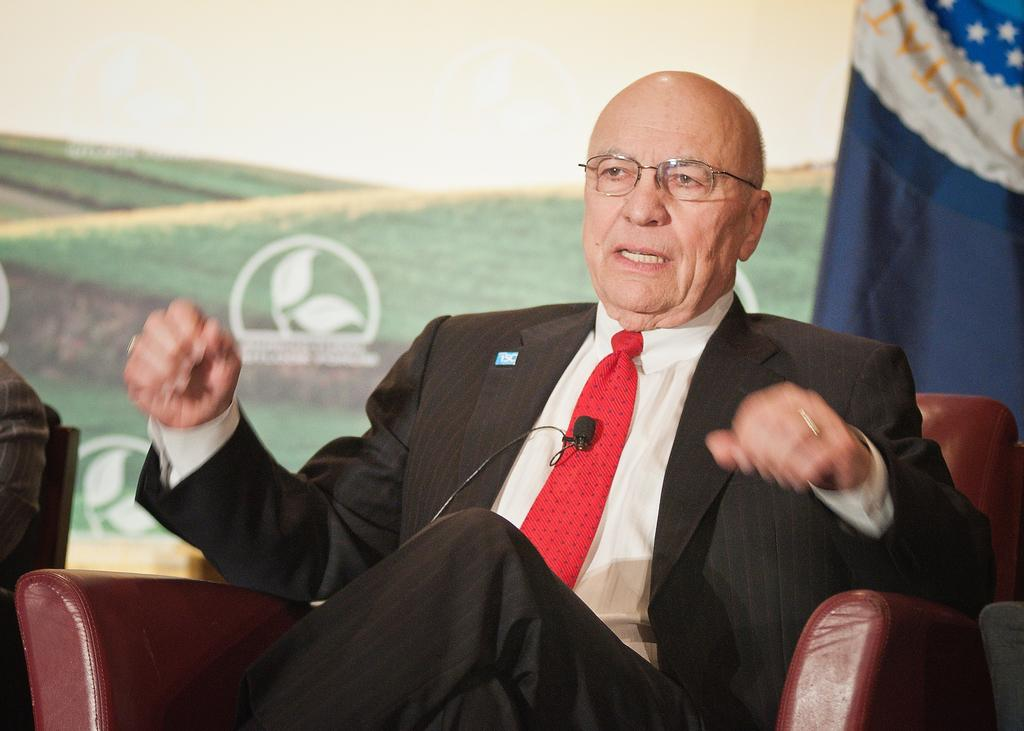What is the man in the image doing? The man is sitting on a chair in the image. How many people are sitting on chairs in the image? There are two people sitting on chairs in the image. What can be seen to the left in the image? There is a blue cloth to the left in the image. What is visible in the background of the image? There is a poster in the background of the image. What type of skirt is the man wearing in the image? The man in the image is not wearing a skirt, as the man is a male figure. 